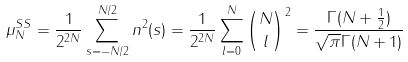Convert formula to latex. <formula><loc_0><loc_0><loc_500><loc_500>\mu _ { N } ^ { S S } = \frac { 1 } { 2 ^ { 2 N } } \sum _ { s = - N / 2 } ^ { N / 2 } n ^ { 2 } ( s ) = \frac { 1 } { 2 ^ { 2 N } } \sum _ { l = 0 } ^ { N } \binom { N } { l } ^ { 2 } = \frac { \Gamma ( N + \frac { 1 } { 2 } ) } { \sqrt { \pi } \Gamma ( N + 1 ) }</formula> 